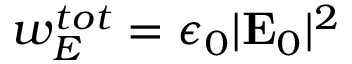<formula> <loc_0><loc_0><loc_500><loc_500>w _ { E } ^ { t o t } = \epsilon _ { 0 } | E _ { 0 } | ^ { 2 }</formula> 